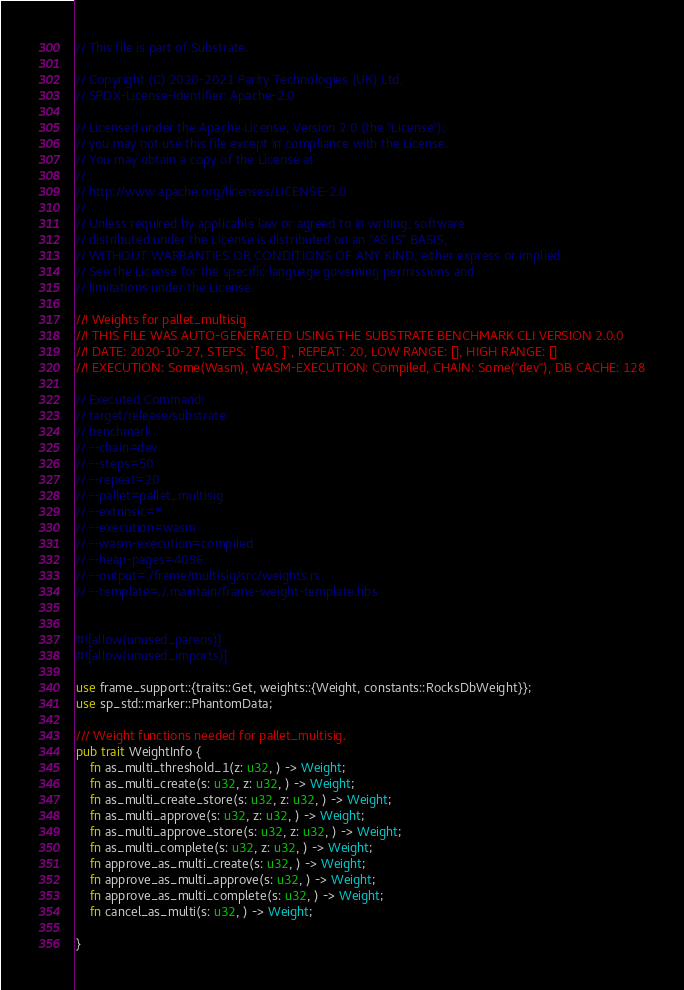<code> <loc_0><loc_0><loc_500><loc_500><_Rust_>// This file is part of Substrate.

// Copyright (C) 2020-2021 Parity Technologies (UK) Ltd.
// SPDX-License-Identifier: Apache-2.0

// Licensed under the Apache License, Version 2.0 (the "License");
// you may not use this file except in compliance with the License.
// You may obtain a copy of the License at
//
// http://www.apache.org/licenses/LICENSE-2.0
//
// Unless required by applicable law or agreed to in writing, software
// distributed under the License is distributed on an "AS IS" BASIS,
// WITHOUT WARRANTIES OR CONDITIONS OF ANY KIND, either express or implied.
// See the License for the specific language governing permissions and
// limitations under the License.

//! Weights for pallet_multisig
//! THIS FILE WAS AUTO-GENERATED USING THE SUBSTRATE BENCHMARK CLI VERSION 2.0.0
//! DATE: 2020-10-27, STEPS: `[50, ]`, REPEAT: 20, LOW RANGE: [], HIGH RANGE: []
//! EXECUTION: Some(Wasm), WASM-EXECUTION: Compiled, CHAIN: Some("dev"), DB CACHE: 128

// Executed Command:
// target/release/substrate
// benchmark
// --chain=dev
// --steps=50
// --repeat=20
// --pallet=pallet_multisig
// --extrinsic=*
// --execution=wasm
// --wasm-execution=compiled
// --heap-pages=4096
// --output=./frame/multisig/src/weights.rs
// --template=./.maintain/frame-weight-template.hbs


#![allow(unused_parens)]
#![allow(unused_imports)]

use frame_support::{traits::Get, weights::{Weight, constants::RocksDbWeight}};
use sp_std::marker::PhantomData;

/// Weight functions needed for pallet_multisig.
pub trait WeightInfo {
	fn as_multi_threshold_1(z: u32, ) -> Weight;
	fn as_multi_create(s: u32, z: u32, ) -> Weight;
	fn as_multi_create_store(s: u32, z: u32, ) -> Weight;
	fn as_multi_approve(s: u32, z: u32, ) -> Weight;
	fn as_multi_approve_store(s: u32, z: u32, ) -> Weight;
	fn as_multi_complete(s: u32, z: u32, ) -> Weight;
	fn approve_as_multi_create(s: u32, ) -> Weight;
	fn approve_as_multi_approve(s: u32, ) -> Weight;
	fn approve_as_multi_complete(s: u32, ) -> Weight;
	fn cancel_as_multi(s: u32, ) -> Weight;
	
}
</code> 